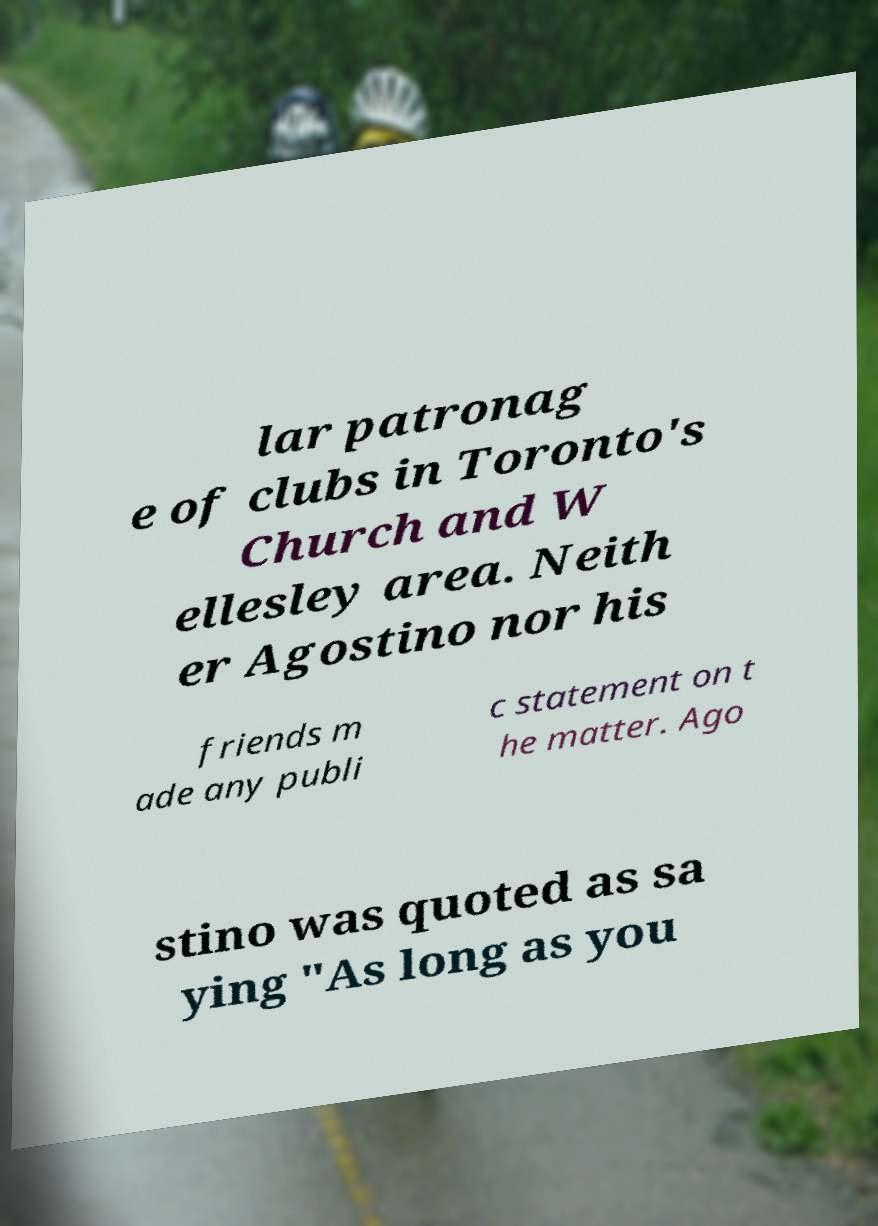What messages or text are displayed in this image? I need them in a readable, typed format. lar patronag e of clubs in Toronto's Church and W ellesley area. Neith er Agostino nor his friends m ade any publi c statement on t he matter. Ago stino was quoted as sa ying "As long as you 